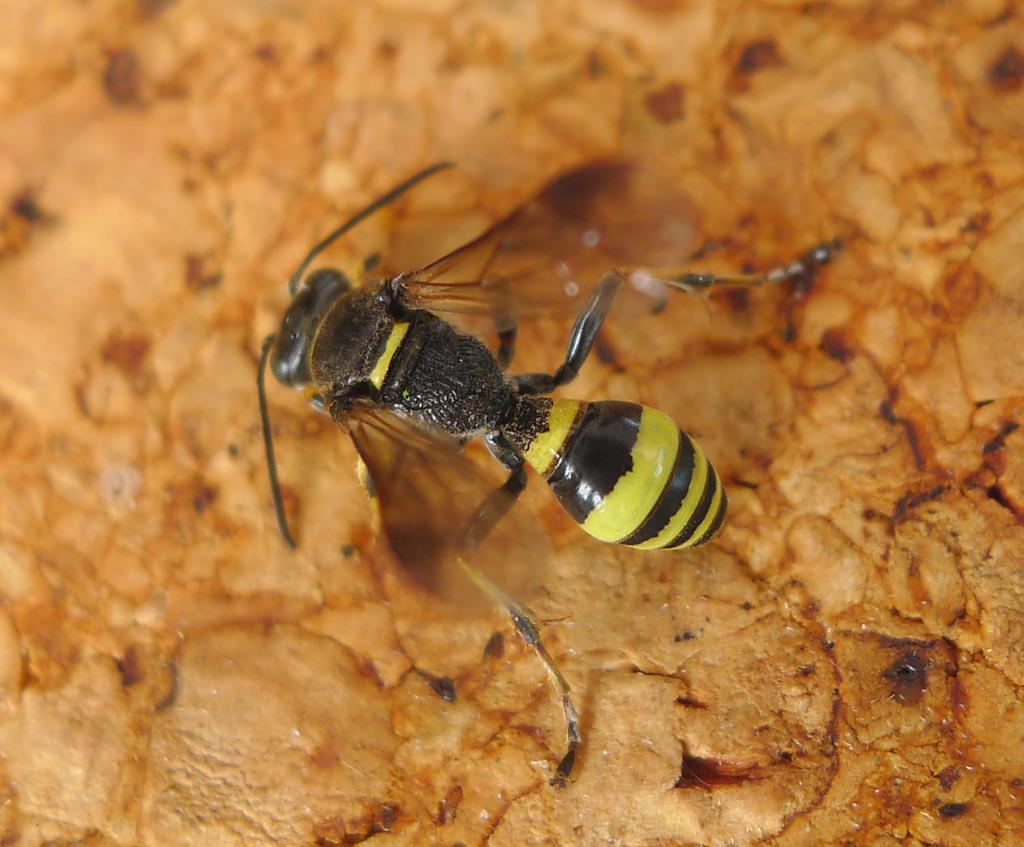What is present in the image? There is an insect in the image. What is the insect laying on? The insect is laying on a cream color surface. What colors can be seen on the insect? The insect has a black and yellow color pattern. How does the insect express anger in the image? There is no indication of the insect expressing anger in the image, as insects do not have emotions like humans. 